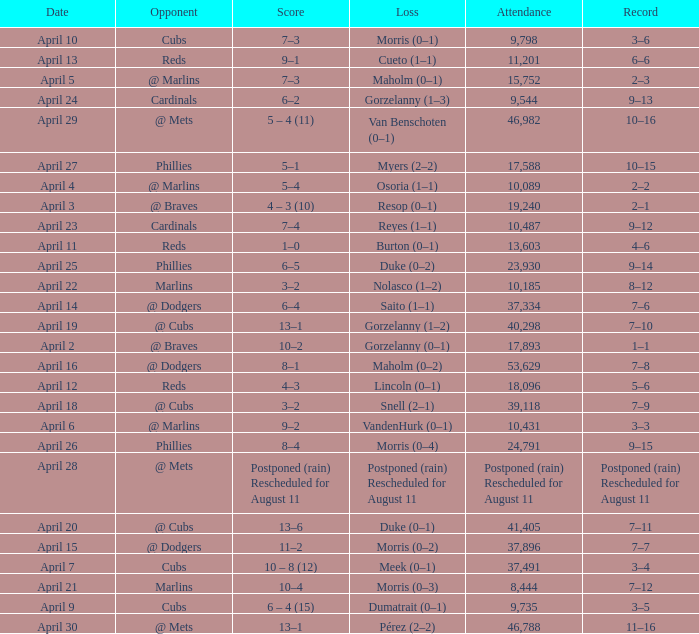What opponent had an attendance of 10,089? @ Marlins. 